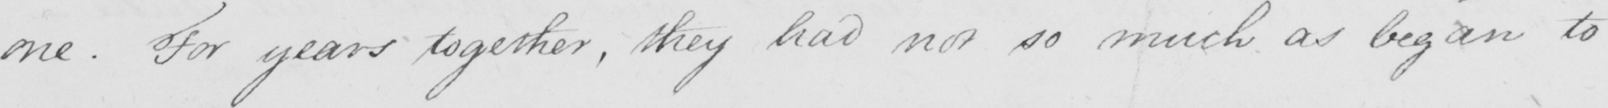Please provide the text content of this handwritten line. one . For years together , they had not so much as began to 